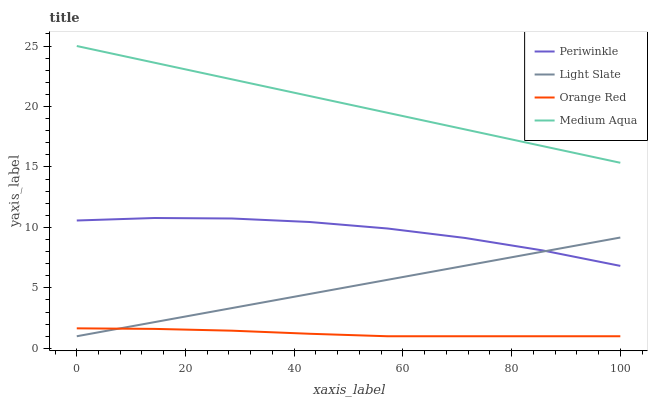Does Orange Red have the minimum area under the curve?
Answer yes or no. Yes. Does Medium Aqua have the maximum area under the curve?
Answer yes or no. Yes. Does Periwinkle have the minimum area under the curve?
Answer yes or no. No. Does Periwinkle have the maximum area under the curve?
Answer yes or no. No. Is Medium Aqua the smoothest?
Answer yes or no. Yes. Is Periwinkle the roughest?
Answer yes or no. Yes. Is Periwinkle the smoothest?
Answer yes or no. No. Is Medium Aqua the roughest?
Answer yes or no. No. Does Light Slate have the lowest value?
Answer yes or no. Yes. Does Periwinkle have the lowest value?
Answer yes or no. No. Does Medium Aqua have the highest value?
Answer yes or no. Yes. Does Periwinkle have the highest value?
Answer yes or no. No. Is Orange Red less than Periwinkle?
Answer yes or no. Yes. Is Medium Aqua greater than Periwinkle?
Answer yes or no. Yes. Does Light Slate intersect Periwinkle?
Answer yes or no. Yes. Is Light Slate less than Periwinkle?
Answer yes or no. No. Is Light Slate greater than Periwinkle?
Answer yes or no. No. Does Orange Red intersect Periwinkle?
Answer yes or no. No. 